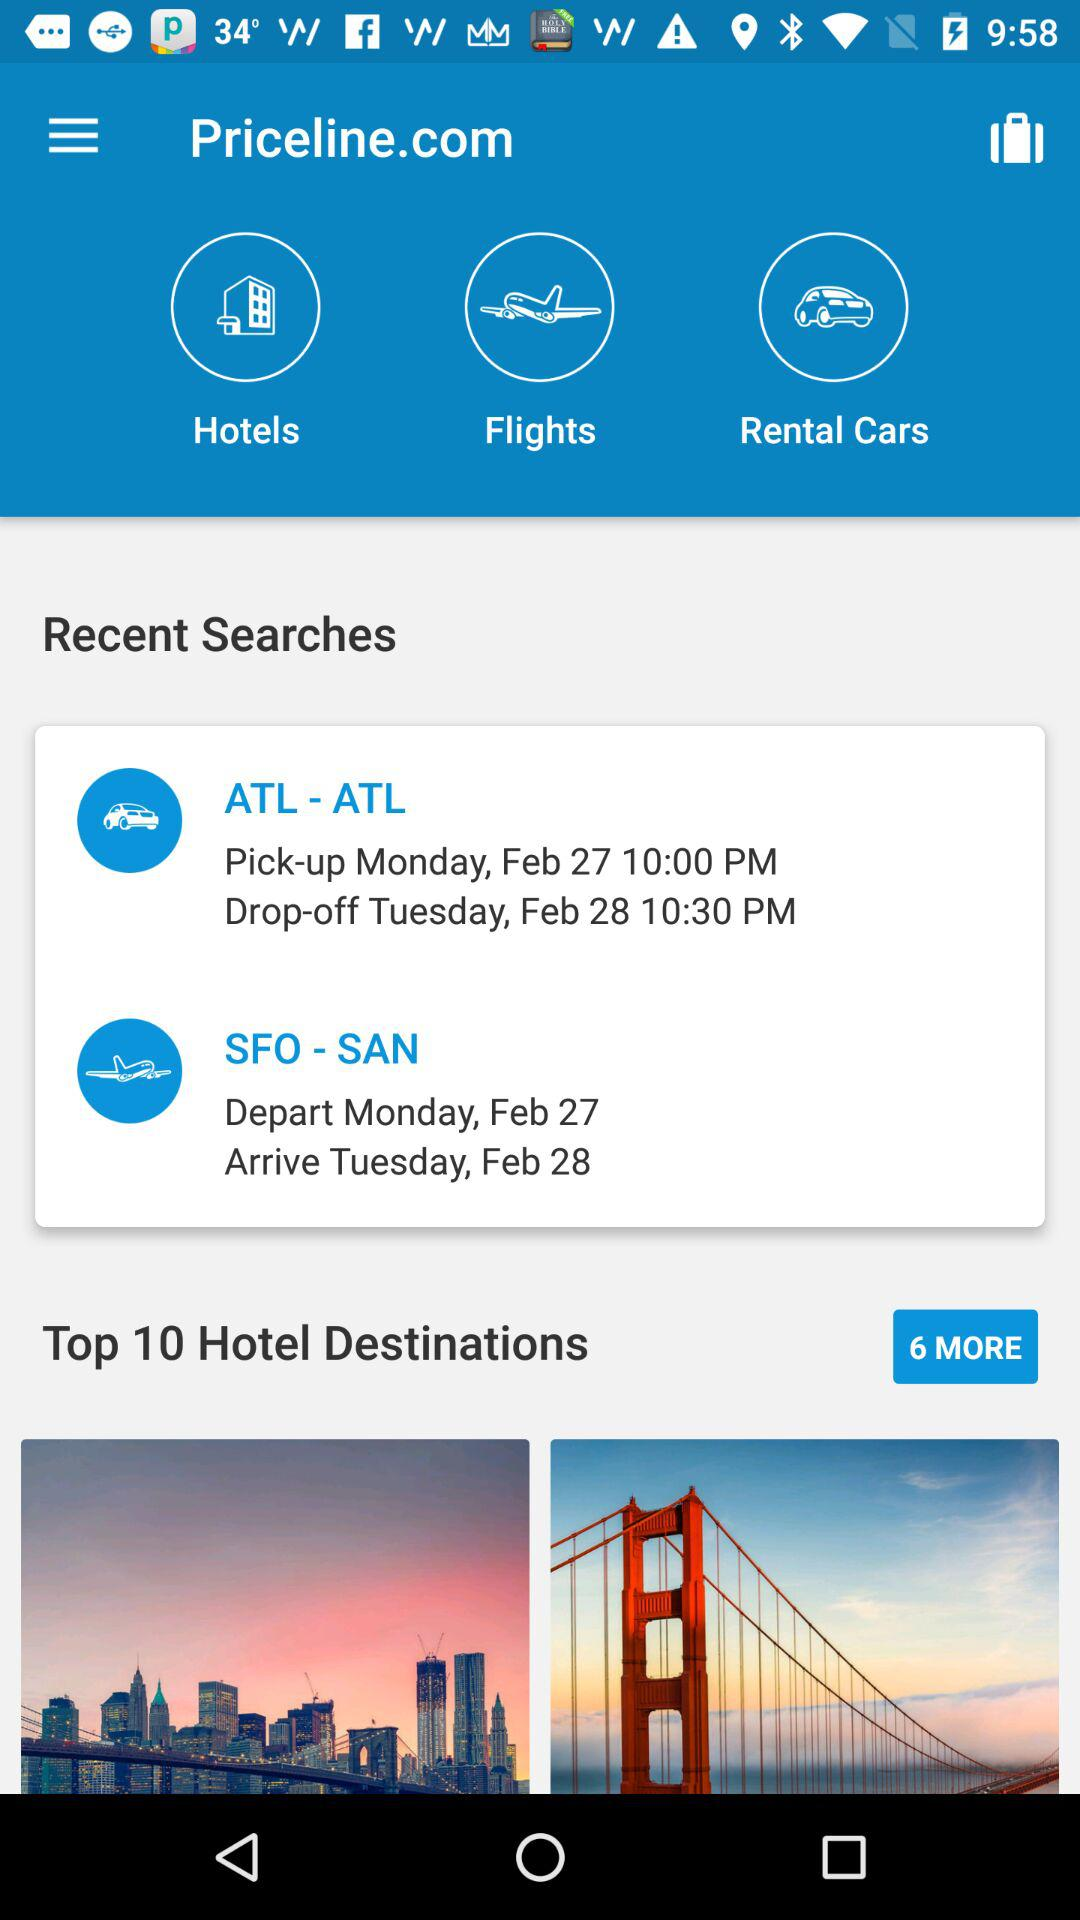What are the recent searches? The recent searches are "ATL - ATL" and "SFO - SAN". 